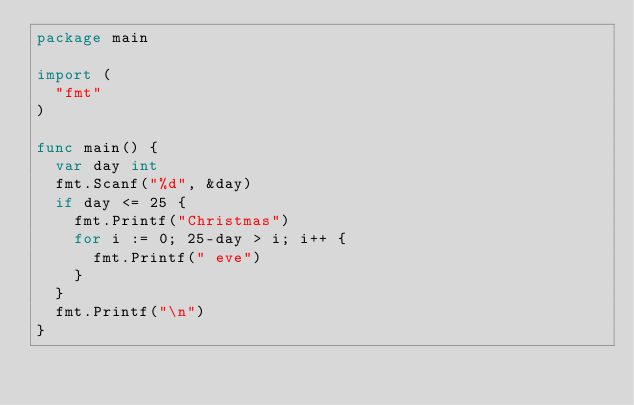<code> <loc_0><loc_0><loc_500><loc_500><_Go_>package main

import (
	"fmt"
)

func main() {
	var day int
	fmt.Scanf("%d", &day)
	if day <= 25 {
		fmt.Printf("Christmas")
		for i := 0; 25-day > i; i++ {
			fmt.Printf(" eve")
		}
	}
	fmt.Printf("\n")
}
</code> 